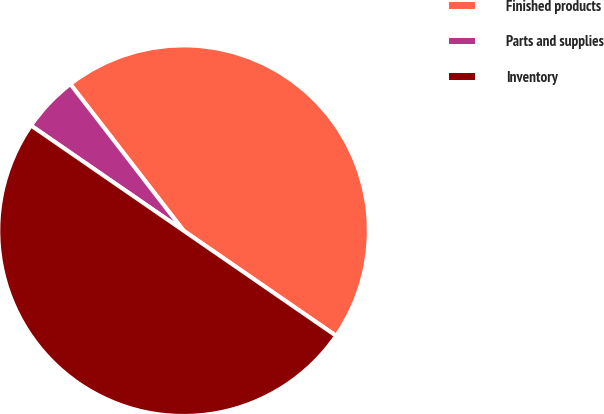Convert chart to OTSL. <chart><loc_0><loc_0><loc_500><loc_500><pie_chart><fcel>Finished products<fcel>Parts and supplies<fcel>Inventory<nl><fcel>45.07%<fcel>4.93%<fcel>50.0%<nl></chart> 